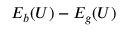Convert formula to latex. <formula><loc_0><loc_0><loc_500><loc_500>E _ { b } ( U ) - E _ { g } ( U )</formula> 